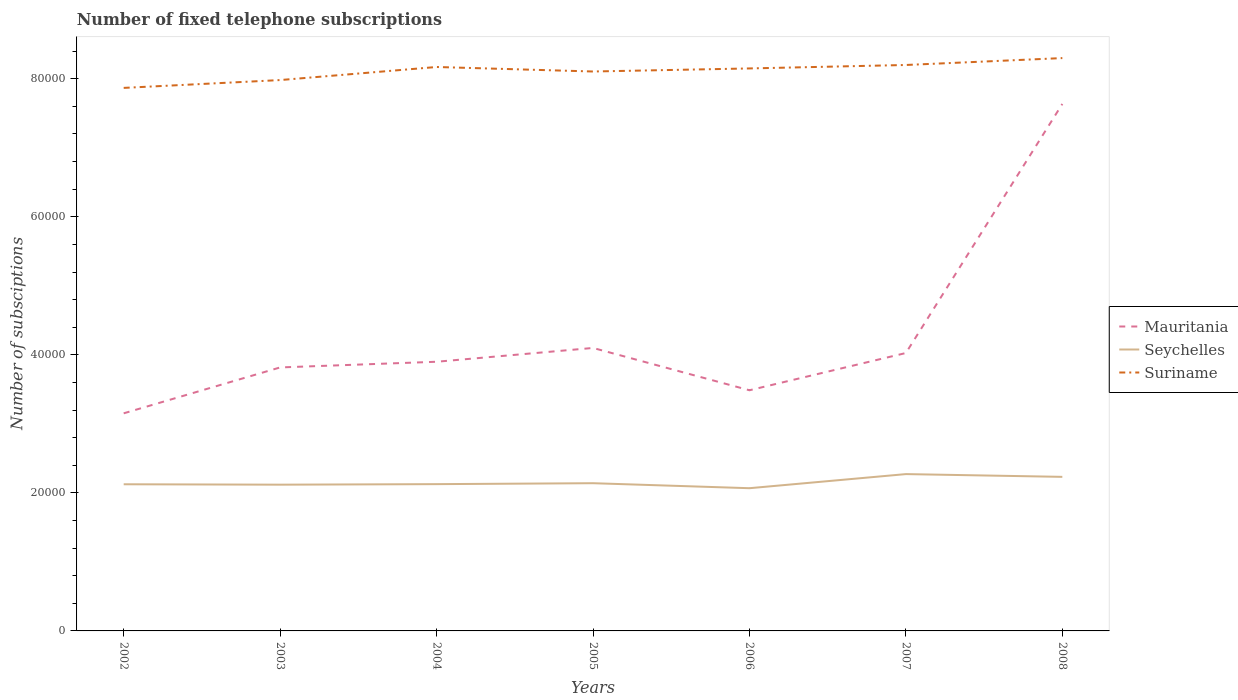Does the line corresponding to Seychelles intersect with the line corresponding to Suriname?
Offer a terse response. No. Is the number of lines equal to the number of legend labels?
Give a very brief answer. Yes. Across all years, what is the maximum number of fixed telephone subscriptions in Suriname?
Ensure brevity in your answer.  7.87e+04. What is the total number of fixed telephone subscriptions in Seychelles in the graph?
Give a very brief answer. -136. What is the difference between the highest and the second highest number of fixed telephone subscriptions in Seychelles?
Offer a terse response. 2043. How many lines are there?
Provide a short and direct response. 3. Does the graph contain any zero values?
Your response must be concise. No. What is the title of the graph?
Your answer should be very brief. Number of fixed telephone subscriptions. What is the label or title of the X-axis?
Provide a succinct answer. Years. What is the label or title of the Y-axis?
Provide a short and direct response. Number of subsciptions. What is the Number of subsciptions in Mauritania in 2002?
Keep it short and to the point. 3.15e+04. What is the Number of subsciptions in Seychelles in 2002?
Keep it short and to the point. 2.12e+04. What is the Number of subsciptions of Suriname in 2002?
Provide a succinct answer. 7.87e+04. What is the Number of subsciptions of Mauritania in 2003?
Ensure brevity in your answer.  3.82e+04. What is the Number of subsciptions of Seychelles in 2003?
Your answer should be compact. 2.12e+04. What is the Number of subsciptions in Suriname in 2003?
Offer a very short reply. 7.98e+04. What is the Number of subsciptions of Mauritania in 2004?
Your answer should be very brief. 3.90e+04. What is the Number of subsciptions in Seychelles in 2004?
Make the answer very short. 2.13e+04. What is the Number of subsciptions in Suriname in 2004?
Your response must be concise. 8.17e+04. What is the Number of subsciptions in Mauritania in 2005?
Give a very brief answer. 4.10e+04. What is the Number of subsciptions of Seychelles in 2005?
Your answer should be compact. 2.14e+04. What is the Number of subsciptions of Suriname in 2005?
Make the answer very short. 8.11e+04. What is the Number of subsciptions in Mauritania in 2006?
Give a very brief answer. 3.49e+04. What is the Number of subsciptions of Seychelles in 2006?
Keep it short and to the point. 2.07e+04. What is the Number of subsciptions of Suriname in 2006?
Give a very brief answer. 8.15e+04. What is the Number of subsciptions of Mauritania in 2007?
Your answer should be compact. 4.03e+04. What is the Number of subsciptions of Seychelles in 2007?
Offer a terse response. 2.27e+04. What is the Number of subsciptions of Suriname in 2007?
Ensure brevity in your answer.  8.20e+04. What is the Number of subsciptions in Mauritania in 2008?
Your answer should be compact. 7.64e+04. What is the Number of subsciptions in Seychelles in 2008?
Your answer should be compact. 2.23e+04. What is the Number of subsciptions of Suriname in 2008?
Ensure brevity in your answer.  8.30e+04. Across all years, what is the maximum Number of subsciptions in Mauritania?
Ensure brevity in your answer.  7.64e+04. Across all years, what is the maximum Number of subsciptions in Seychelles?
Your response must be concise. 2.27e+04. Across all years, what is the maximum Number of subsciptions of Suriname?
Your response must be concise. 8.30e+04. Across all years, what is the minimum Number of subsciptions in Mauritania?
Your answer should be compact. 3.15e+04. Across all years, what is the minimum Number of subsciptions of Seychelles?
Your response must be concise. 2.07e+04. Across all years, what is the minimum Number of subsciptions in Suriname?
Provide a short and direct response. 7.87e+04. What is the total Number of subsciptions of Mauritania in the graph?
Your answer should be compact. 3.01e+05. What is the total Number of subsciptions in Seychelles in the graph?
Offer a terse response. 1.51e+05. What is the total Number of subsciptions in Suriname in the graph?
Your response must be concise. 5.68e+05. What is the difference between the Number of subsciptions of Mauritania in 2002 and that in 2003?
Your answer should be compact. -6649. What is the difference between the Number of subsciptions of Suriname in 2002 and that in 2003?
Provide a short and direct response. -1135. What is the difference between the Number of subsciptions of Mauritania in 2002 and that in 2004?
Your answer should be compact. -7471. What is the difference between the Number of subsciptions in Suriname in 2002 and that in 2004?
Provide a succinct answer. -3029. What is the difference between the Number of subsciptions of Mauritania in 2002 and that in 2005?
Your answer should be very brief. -9471. What is the difference between the Number of subsciptions in Seychelles in 2002 and that in 2005?
Your answer should be compact. -155. What is the difference between the Number of subsciptions in Suriname in 2002 and that in 2005?
Your answer should be very brief. -2376. What is the difference between the Number of subsciptions of Mauritania in 2002 and that in 2006?
Make the answer very short. -3341. What is the difference between the Number of subsciptions of Seychelles in 2002 and that in 2006?
Offer a terse response. 570. What is the difference between the Number of subsciptions in Suriname in 2002 and that in 2006?
Provide a short and direct response. -2820. What is the difference between the Number of subsciptions of Mauritania in 2002 and that in 2007?
Provide a short and direct response. -8738. What is the difference between the Number of subsciptions of Seychelles in 2002 and that in 2007?
Keep it short and to the point. -1473. What is the difference between the Number of subsciptions in Suriname in 2002 and that in 2007?
Offer a very short reply. -3320. What is the difference between the Number of subsciptions in Mauritania in 2002 and that in 2008?
Your answer should be very brief. -4.48e+04. What is the difference between the Number of subsciptions of Seychelles in 2002 and that in 2008?
Provide a succinct answer. -1073. What is the difference between the Number of subsciptions in Suriname in 2002 and that in 2008?
Offer a terse response. -4320. What is the difference between the Number of subsciptions of Mauritania in 2003 and that in 2004?
Your answer should be very brief. -822. What is the difference between the Number of subsciptions of Seychelles in 2003 and that in 2004?
Provide a short and direct response. -77. What is the difference between the Number of subsciptions in Suriname in 2003 and that in 2004?
Keep it short and to the point. -1894. What is the difference between the Number of subsciptions of Mauritania in 2003 and that in 2005?
Your answer should be compact. -2822. What is the difference between the Number of subsciptions of Seychelles in 2003 and that in 2005?
Ensure brevity in your answer.  -213. What is the difference between the Number of subsciptions in Suriname in 2003 and that in 2005?
Provide a succinct answer. -1241. What is the difference between the Number of subsciptions of Mauritania in 2003 and that in 2006?
Your answer should be very brief. 3308. What is the difference between the Number of subsciptions in Seychelles in 2003 and that in 2006?
Provide a short and direct response. 512. What is the difference between the Number of subsciptions in Suriname in 2003 and that in 2006?
Provide a succinct answer. -1685. What is the difference between the Number of subsciptions in Mauritania in 2003 and that in 2007?
Give a very brief answer. -2089. What is the difference between the Number of subsciptions of Seychelles in 2003 and that in 2007?
Ensure brevity in your answer.  -1531. What is the difference between the Number of subsciptions of Suriname in 2003 and that in 2007?
Offer a terse response. -2185. What is the difference between the Number of subsciptions in Mauritania in 2003 and that in 2008?
Your answer should be compact. -3.82e+04. What is the difference between the Number of subsciptions in Seychelles in 2003 and that in 2008?
Your answer should be compact. -1131. What is the difference between the Number of subsciptions of Suriname in 2003 and that in 2008?
Make the answer very short. -3185. What is the difference between the Number of subsciptions in Mauritania in 2004 and that in 2005?
Provide a short and direct response. -2000. What is the difference between the Number of subsciptions of Seychelles in 2004 and that in 2005?
Your response must be concise. -136. What is the difference between the Number of subsciptions in Suriname in 2004 and that in 2005?
Your response must be concise. 653. What is the difference between the Number of subsciptions of Mauritania in 2004 and that in 2006?
Your response must be concise. 4130. What is the difference between the Number of subsciptions in Seychelles in 2004 and that in 2006?
Keep it short and to the point. 589. What is the difference between the Number of subsciptions in Suriname in 2004 and that in 2006?
Offer a terse response. 209. What is the difference between the Number of subsciptions of Mauritania in 2004 and that in 2007?
Provide a succinct answer. -1267. What is the difference between the Number of subsciptions in Seychelles in 2004 and that in 2007?
Offer a terse response. -1454. What is the difference between the Number of subsciptions in Suriname in 2004 and that in 2007?
Your answer should be compact. -291. What is the difference between the Number of subsciptions of Mauritania in 2004 and that in 2008?
Keep it short and to the point. -3.74e+04. What is the difference between the Number of subsciptions in Seychelles in 2004 and that in 2008?
Provide a succinct answer. -1054. What is the difference between the Number of subsciptions of Suriname in 2004 and that in 2008?
Ensure brevity in your answer.  -1291. What is the difference between the Number of subsciptions in Mauritania in 2005 and that in 2006?
Give a very brief answer. 6130. What is the difference between the Number of subsciptions of Seychelles in 2005 and that in 2006?
Your answer should be compact. 725. What is the difference between the Number of subsciptions in Suriname in 2005 and that in 2006?
Your answer should be very brief. -444. What is the difference between the Number of subsciptions of Mauritania in 2005 and that in 2007?
Keep it short and to the point. 733. What is the difference between the Number of subsciptions in Seychelles in 2005 and that in 2007?
Your answer should be very brief. -1318. What is the difference between the Number of subsciptions of Suriname in 2005 and that in 2007?
Your response must be concise. -944. What is the difference between the Number of subsciptions in Mauritania in 2005 and that in 2008?
Keep it short and to the point. -3.54e+04. What is the difference between the Number of subsciptions of Seychelles in 2005 and that in 2008?
Ensure brevity in your answer.  -918. What is the difference between the Number of subsciptions of Suriname in 2005 and that in 2008?
Give a very brief answer. -1944. What is the difference between the Number of subsciptions of Mauritania in 2006 and that in 2007?
Your answer should be very brief. -5397. What is the difference between the Number of subsciptions of Seychelles in 2006 and that in 2007?
Ensure brevity in your answer.  -2043. What is the difference between the Number of subsciptions in Suriname in 2006 and that in 2007?
Offer a terse response. -500. What is the difference between the Number of subsciptions in Mauritania in 2006 and that in 2008?
Your answer should be very brief. -4.15e+04. What is the difference between the Number of subsciptions in Seychelles in 2006 and that in 2008?
Your answer should be compact. -1643. What is the difference between the Number of subsciptions of Suriname in 2006 and that in 2008?
Offer a terse response. -1500. What is the difference between the Number of subsciptions of Mauritania in 2007 and that in 2008?
Your answer should be compact. -3.61e+04. What is the difference between the Number of subsciptions in Suriname in 2007 and that in 2008?
Your answer should be compact. -1000. What is the difference between the Number of subsciptions in Mauritania in 2002 and the Number of subsciptions in Seychelles in 2003?
Offer a terse response. 1.03e+04. What is the difference between the Number of subsciptions in Mauritania in 2002 and the Number of subsciptions in Suriname in 2003?
Your answer should be very brief. -4.83e+04. What is the difference between the Number of subsciptions in Seychelles in 2002 and the Number of subsciptions in Suriname in 2003?
Offer a terse response. -5.86e+04. What is the difference between the Number of subsciptions in Mauritania in 2002 and the Number of subsciptions in Seychelles in 2004?
Provide a succinct answer. 1.03e+04. What is the difference between the Number of subsciptions of Mauritania in 2002 and the Number of subsciptions of Suriname in 2004?
Your answer should be very brief. -5.02e+04. What is the difference between the Number of subsciptions in Seychelles in 2002 and the Number of subsciptions in Suriname in 2004?
Keep it short and to the point. -6.05e+04. What is the difference between the Number of subsciptions in Mauritania in 2002 and the Number of subsciptions in Seychelles in 2005?
Offer a terse response. 1.01e+04. What is the difference between the Number of subsciptions in Mauritania in 2002 and the Number of subsciptions in Suriname in 2005?
Ensure brevity in your answer.  -4.95e+04. What is the difference between the Number of subsciptions of Seychelles in 2002 and the Number of subsciptions of Suriname in 2005?
Provide a short and direct response. -5.98e+04. What is the difference between the Number of subsciptions of Mauritania in 2002 and the Number of subsciptions of Seychelles in 2006?
Your response must be concise. 1.08e+04. What is the difference between the Number of subsciptions of Mauritania in 2002 and the Number of subsciptions of Suriname in 2006?
Your answer should be compact. -5.00e+04. What is the difference between the Number of subsciptions of Seychelles in 2002 and the Number of subsciptions of Suriname in 2006?
Offer a very short reply. -6.03e+04. What is the difference between the Number of subsciptions of Mauritania in 2002 and the Number of subsciptions of Seychelles in 2007?
Make the answer very short. 8807. What is the difference between the Number of subsciptions in Mauritania in 2002 and the Number of subsciptions in Suriname in 2007?
Make the answer very short. -5.05e+04. What is the difference between the Number of subsciptions in Seychelles in 2002 and the Number of subsciptions in Suriname in 2007?
Your answer should be very brief. -6.08e+04. What is the difference between the Number of subsciptions in Mauritania in 2002 and the Number of subsciptions in Seychelles in 2008?
Keep it short and to the point. 9207. What is the difference between the Number of subsciptions in Mauritania in 2002 and the Number of subsciptions in Suriname in 2008?
Provide a succinct answer. -5.15e+04. What is the difference between the Number of subsciptions of Seychelles in 2002 and the Number of subsciptions of Suriname in 2008?
Offer a terse response. -6.18e+04. What is the difference between the Number of subsciptions in Mauritania in 2003 and the Number of subsciptions in Seychelles in 2004?
Your answer should be very brief. 1.69e+04. What is the difference between the Number of subsciptions in Mauritania in 2003 and the Number of subsciptions in Suriname in 2004?
Your response must be concise. -4.35e+04. What is the difference between the Number of subsciptions of Seychelles in 2003 and the Number of subsciptions of Suriname in 2004?
Ensure brevity in your answer.  -6.05e+04. What is the difference between the Number of subsciptions of Mauritania in 2003 and the Number of subsciptions of Seychelles in 2005?
Keep it short and to the point. 1.68e+04. What is the difference between the Number of subsciptions of Mauritania in 2003 and the Number of subsciptions of Suriname in 2005?
Your response must be concise. -4.29e+04. What is the difference between the Number of subsciptions in Seychelles in 2003 and the Number of subsciptions in Suriname in 2005?
Keep it short and to the point. -5.99e+04. What is the difference between the Number of subsciptions in Mauritania in 2003 and the Number of subsciptions in Seychelles in 2006?
Your response must be concise. 1.75e+04. What is the difference between the Number of subsciptions of Mauritania in 2003 and the Number of subsciptions of Suriname in 2006?
Offer a terse response. -4.33e+04. What is the difference between the Number of subsciptions in Seychelles in 2003 and the Number of subsciptions in Suriname in 2006?
Keep it short and to the point. -6.03e+04. What is the difference between the Number of subsciptions in Mauritania in 2003 and the Number of subsciptions in Seychelles in 2007?
Your response must be concise. 1.55e+04. What is the difference between the Number of subsciptions in Mauritania in 2003 and the Number of subsciptions in Suriname in 2007?
Give a very brief answer. -4.38e+04. What is the difference between the Number of subsciptions in Seychelles in 2003 and the Number of subsciptions in Suriname in 2007?
Your response must be concise. -6.08e+04. What is the difference between the Number of subsciptions in Mauritania in 2003 and the Number of subsciptions in Seychelles in 2008?
Make the answer very short. 1.59e+04. What is the difference between the Number of subsciptions in Mauritania in 2003 and the Number of subsciptions in Suriname in 2008?
Offer a terse response. -4.48e+04. What is the difference between the Number of subsciptions of Seychelles in 2003 and the Number of subsciptions of Suriname in 2008?
Provide a succinct answer. -6.18e+04. What is the difference between the Number of subsciptions in Mauritania in 2004 and the Number of subsciptions in Seychelles in 2005?
Keep it short and to the point. 1.76e+04. What is the difference between the Number of subsciptions in Mauritania in 2004 and the Number of subsciptions in Suriname in 2005?
Your answer should be very brief. -4.21e+04. What is the difference between the Number of subsciptions of Seychelles in 2004 and the Number of subsciptions of Suriname in 2005?
Provide a short and direct response. -5.98e+04. What is the difference between the Number of subsciptions of Mauritania in 2004 and the Number of subsciptions of Seychelles in 2006?
Give a very brief answer. 1.83e+04. What is the difference between the Number of subsciptions in Mauritania in 2004 and the Number of subsciptions in Suriname in 2006?
Provide a succinct answer. -4.25e+04. What is the difference between the Number of subsciptions of Seychelles in 2004 and the Number of subsciptions of Suriname in 2006?
Provide a succinct answer. -6.02e+04. What is the difference between the Number of subsciptions of Mauritania in 2004 and the Number of subsciptions of Seychelles in 2007?
Make the answer very short. 1.63e+04. What is the difference between the Number of subsciptions in Mauritania in 2004 and the Number of subsciptions in Suriname in 2007?
Offer a terse response. -4.30e+04. What is the difference between the Number of subsciptions of Seychelles in 2004 and the Number of subsciptions of Suriname in 2007?
Keep it short and to the point. -6.07e+04. What is the difference between the Number of subsciptions in Mauritania in 2004 and the Number of subsciptions in Seychelles in 2008?
Your response must be concise. 1.67e+04. What is the difference between the Number of subsciptions in Mauritania in 2004 and the Number of subsciptions in Suriname in 2008?
Your answer should be very brief. -4.40e+04. What is the difference between the Number of subsciptions of Seychelles in 2004 and the Number of subsciptions of Suriname in 2008?
Your answer should be compact. -6.17e+04. What is the difference between the Number of subsciptions of Mauritania in 2005 and the Number of subsciptions of Seychelles in 2006?
Provide a short and direct response. 2.03e+04. What is the difference between the Number of subsciptions of Mauritania in 2005 and the Number of subsciptions of Suriname in 2006?
Make the answer very short. -4.05e+04. What is the difference between the Number of subsciptions in Seychelles in 2005 and the Number of subsciptions in Suriname in 2006?
Offer a terse response. -6.01e+04. What is the difference between the Number of subsciptions of Mauritania in 2005 and the Number of subsciptions of Seychelles in 2007?
Keep it short and to the point. 1.83e+04. What is the difference between the Number of subsciptions of Mauritania in 2005 and the Number of subsciptions of Suriname in 2007?
Give a very brief answer. -4.10e+04. What is the difference between the Number of subsciptions in Seychelles in 2005 and the Number of subsciptions in Suriname in 2007?
Provide a short and direct response. -6.06e+04. What is the difference between the Number of subsciptions of Mauritania in 2005 and the Number of subsciptions of Seychelles in 2008?
Provide a succinct answer. 1.87e+04. What is the difference between the Number of subsciptions of Mauritania in 2005 and the Number of subsciptions of Suriname in 2008?
Your answer should be compact. -4.20e+04. What is the difference between the Number of subsciptions in Seychelles in 2005 and the Number of subsciptions in Suriname in 2008?
Provide a succinct answer. -6.16e+04. What is the difference between the Number of subsciptions of Mauritania in 2006 and the Number of subsciptions of Seychelles in 2007?
Give a very brief answer. 1.21e+04. What is the difference between the Number of subsciptions of Mauritania in 2006 and the Number of subsciptions of Suriname in 2007?
Ensure brevity in your answer.  -4.71e+04. What is the difference between the Number of subsciptions of Seychelles in 2006 and the Number of subsciptions of Suriname in 2007?
Your answer should be very brief. -6.13e+04. What is the difference between the Number of subsciptions of Mauritania in 2006 and the Number of subsciptions of Seychelles in 2008?
Make the answer very short. 1.25e+04. What is the difference between the Number of subsciptions in Mauritania in 2006 and the Number of subsciptions in Suriname in 2008?
Your answer should be compact. -4.81e+04. What is the difference between the Number of subsciptions of Seychelles in 2006 and the Number of subsciptions of Suriname in 2008?
Your response must be concise. -6.23e+04. What is the difference between the Number of subsciptions in Mauritania in 2007 and the Number of subsciptions in Seychelles in 2008?
Keep it short and to the point. 1.79e+04. What is the difference between the Number of subsciptions in Mauritania in 2007 and the Number of subsciptions in Suriname in 2008?
Make the answer very short. -4.27e+04. What is the difference between the Number of subsciptions in Seychelles in 2007 and the Number of subsciptions in Suriname in 2008?
Give a very brief answer. -6.03e+04. What is the average Number of subsciptions in Mauritania per year?
Keep it short and to the point. 4.30e+04. What is the average Number of subsciptions in Seychelles per year?
Your answer should be compact. 2.15e+04. What is the average Number of subsciptions in Suriname per year?
Provide a succinct answer. 8.11e+04. In the year 2002, what is the difference between the Number of subsciptions in Mauritania and Number of subsciptions in Seychelles?
Provide a succinct answer. 1.03e+04. In the year 2002, what is the difference between the Number of subsciptions of Mauritania and Number of subsciptions of Suriname?
Keep it short and to the point. -4.72e+04. In the year 2002, what is the difference between the Number of subsciptions in Seychelles and Number of subsciptions in Suriname?
Your answer should be very brief. -5.74e+04. In the year 2003, what is the difference between the Number of subsciptions of Mauritania and Number of subsciptions of Seychelles?
Make the answer very short. 1.70e+04. In the year 2003, what is the difference between the Number of subsciptions in Mauritania and Number of subsciptions in Suriname?
Your response must be concise. -4.16e+04. In the year 2003, what is the difference between the Number of subsciptions of Seychelles and Number of subsciptions of Suriname?
Provide a succinct answer. -5.86e+04. In the year 2004, what is the difference between the Number of subsciptions of Mauritania and Number of subsciptions of Seychelles?
Your answer should be compact. 1.77e+04. In the year 2004, what is the difference between the Number of subsciptions of Mauritania and Number of subsciptions of Suriname?
Make the answer very short. -4.27e+04. In the year 2004, what is the difference between the Number of subsciptions in Seychelles and Number of subsciptions in Suriname?
Make the answer very short. -6.04e+04. In the year 2005, what is the difference between the Number of subsciptions of Mauritania and Number of subsciptions of Seychelles?
Your response must be concise. 1.96e+04. In the year 2005, what is the difference between the Number of subsciptions in Mauritania and Number of subsciptions in Suriname?
Your answer should be very brief. -4.01e+04. In the year 2005, what is the difference between the Number of subsciptions of Seychelles and Number of subsciptions of Suriname?
Your response must be concise. -5.97e+04. In the year 2006, what is the difference between the Number of subsciptions of Mauritania and Number of subsciptions of Seychelles?
Your response must be concise. 1.42e+04. In the year 2006, what is the difference between the Number of subsciptions in Mauritania and Number of subsciptions in Suriname?
Your answer should be very brief. -4.66e+04. In the year 2006, what is the difference between the Number of subsciptions of Seychelles and Number of subsciptions of Suriname?
Keep it short and to the point. -6.08e+04. In the year 2007, what is the difference between the Number of subsciptions in Mauritania and Number of subsciptions in Seychelles?
Provide a short and direct response. 1.75e+04. In the year 2007, what is the difference between the Number of subsciptions of Mauritania and Number of subsciptions of Suriname?
Your response must be concise. -4.17e+04. In the year 2007, what is the difference between the Number of subsciptions of Seychelles and Number of subsciptions of Suriname?
Offer a terse response. -5.93e+04. In the year 2008, what is the difference between the Number of subsciptions in Mauritania and Number of subsciptions in Seychelles?
Your answer should be compact. 5.40e+04. In the year 2008, what is the difference between the Number of subsciptions in Mauritania and Number of subsciptions in Suriname?
Give a very brief answer. -6646. In the year 2008, what is the difference between the Number of subsciptions of Seychelles and Number of subsciptions of Suriname?
Make the answer very short. -6.07e+04. What is the ratio of the Number of subsciptions of Mauritania in 2002 to that in 2003?
Provide a succinct answer. 0.83. What is the ratio of the Number of subsciptions in Seychelles in 2002 to that in 2003?
Ensure brevity in your answer.  1. What is the ratio of the Number of subsciptions of Suriname in 2002 to that in 2003?
Ensure brevity in your answer.  0.99. What is the ratio of the Number of subsciptions in Mauritania in 2002 to that in 2004?
Your response must be concise. 0.81. What is the ratio of the Number of subsciptions of Suriname in 2002 to that in 2004?
Provide a short and direct response. 0.96. What is the ratio of the Number of subsciptions of Mauritania in 2002 to that in 2005?
Your response must be concise. 0.77. What is the ratio of the Number of subsciptions of Seychelles in 2002 to that in 2005?
Give a very brief answer. 0.99. What is the ratio of the Number of subsciptions of Suriname in 2002 to that in 2005?
Offer a very short reply. 0.97. What is the ratio of the Number of subsciptions of Mauritania in 2002 to that in 2006?
Provide a short and direct response. 0.9. What is the ratio of the Number of subsciptions in Seychelles in 2002 to that in 2006?
Keep it short and to the point. 1.03. What is the ratio of the Number of subsciptions in Suriname in 2002 to that in 2006?
Make the answer very short. 0.97. What is the ratio of the Number of subsciptions in Mauritania in 2002 to that in 2007?
Offer a terse response. 0.78. What is the ratio of the Number of subsciptions in Seychelles in 2002 to that in 2007?
Provide a short and direct response. 0.94. What is the ratio of the Number of subsciptions of Suriname in 2002 to that in 2007?
Offer a very short reply. 0.96. What is the ratio of the Number of subsciptions in Mauritania in 2002 to that in 2008?
Provide a succinct answer. 0.41. What is the ratio of the Number of subsciptions of Seychelles in 2002 to that in 2008?
Ensure brevity in your answer.  0.95. What is the ratio of the Number of subsciptions of Suriname in 2002 to that in 2008?
Give a very brief answer. 0.95. What is the ratio of the Number of subsciptions in Mauritania in 2003 to that in 2004?
Make the answer very short. 0.98. What is the ratio of the Number of subsciptions of Seychelles in 2003 to that in 2004?
Make the answer very short. 1. What is the ratio of the Number of subsciptions of Suriname in 2003 to that in 2004?
Keep it short and to the point. 0.98. What is the ratio of the Number of subsciptions in Mauritania in 2003 to that in 2005?
Provide a succinct answer. 0.93. What is the ratio of the Number of subsciptions in Seychelles in 2003 to that in 2005?
Your response must be concise. 0.99. What is the ratio of the Number of subsciptions in Suriname in 2003 to that in 2005?
Keep it short and to the point. 0.98. What is the ratio of the Number of subsciptions of Mauritania in 2003 to that in 2006?
Provide a succinct answer. 1.09. What is the ratio of the Number of subsciptions of Seychelles in 2003 to that in 2006?
Offer a terse response. 1.02. What is the ratio of the Number of subsciptions in Suriname in 2003 to that in 2006?
Your answer should be compact. 0.98. What is the ratio of the Number of subsciptions in Mauritania in 2003 to that in 2007?
Your answer should be compact. 0.95. What is the ratio of the Number of subsciptions of Seychelles in 2003 to that in 2007?
Your answer should be very brief. 0.93. What is the ratio of the Number of subsciptions in Suriname in 2003 to that in 2007?
Provide a succinct answer. 0.97. What is the ratio of the Number of subsciptions of Mauritania in 2003 to that in 2008?
Keep it short and to the point. 0.5. What is the ratio of the Number of subsciptions in Seychelles in 2003 to that in 2008?
Your answer should be compact. 0.95. What is the ratio of the Number of subsciptions in Suriname in 2003 to that in 2008?
Ensure brevity in your answer.  0.96. What is the ratio of the Number of subsciptions in Mauritania in 2004 to that in 2005?
Your answer should be very brief. 0.95. What is the ratio of the Number of subsciptions in Seychelles in 2004 to that in 2005?
Ensure brevity in your answer.  0.99. What is the ratio of the Number of subsciptions in Mauritania in 2004 to that in 2006?
Your answer should be very brief. 1.12. What is the ratio of the Number of subsciptions in Seychelles in 2004 to that in 2006?
Make the answer very short. 1.03. What is the ratio of the Number of subsciptions in Mauritania in 2004 to that in 2007?
Keep it short and to the point. 0.97. What is the ratio of the Number of subsciptions in Seychelles in 2004 to that in 2007?
Ensure brevity in your answer.  0.94. What is the ratio of the Number of subsciptions of Mauritania in 2004 to that in 2008?
Make the answer very short. 0.51. What is the ratio of the Number of subsciptions in Seychelles in 2004 to that in 2008?
Give a very brief answer. 0.95. What is the ratio of the Number of subsciptions of Suriname in 2004 to that in 2008?
Ensure brevity in your answer.  0.98. What is the ratio of the Number of subsciptions in Mauritania in 2005 to that in 2006?
Give a very brief answer. 1.18. What is the ratio of the Number of subsciptions in Seychelles in 2005 to that in 2006?
Your answer should be very brief. 1.04. What is the ratio of the Number of subsciptions of Suriname in 2005 to that in 2006?
Keep it short and to the point. 0.99. What is the ratio of the Number of subsciptions in Mauritania in 2005 to that in 2007?
Ensure brevity in your answer.  1.02. What is the ratio of the Number of subsciptions of Seychelles in 2005 to that in 2007?
Keep it short and to the point. 0.94. What is the ratio of the Number of subsciptions of Suriname in 2005 to that in 2007?
Provide a short and direct response. 0.99. What is the ratio of the Number of subsciptions of Mauritania in 2005 to that in 2008?
Make the answer very short. 0.54. What is the ratio of the Number of subsciptions of Seychelles in 2005 to that in 2008?
Make the answer very short. 0.96. What is the ratio of the Number of subsciptions of Suriname in 2005 to that in 2008?
Provide a succinct answer. 0.98. What is the ratio of the Number of subsciptions of Mauritania in 2006 to that in 2007?
Your answer should be very brief. 0.87. What is the ratio of the Number of subsciptions of Seychelles in 2006 to that in 2007?
Your answer should be very brief. 0.91. What is the ratio of the Number of subsciptions in Suriname in 2006 to that in 2007?
Provide a short and direct response. 0.99. What is the ratio of the Number of subsciptions of Mauritania in 2006 to that in 2008?
Provide a succinct answer. 0.46. What is the ratio of the Number of subsciptions in Seychelles in 2006 to that in 2008?
Offer a terse response. 0.93. What is the ratio of the Number of subsciptions of Suriname in 2006 to that in 2008?
Provide a succinct answer. 0.98. What is the ratio of the Number of subsciptions in Mauritania in 2007 to that in 2008?
Give a very brief answer. 0.53. What is the ratio of the Number of subsciptions in Seychelles in 2007 to that in 2008?
Your answer should be compact. 1.02. What is the ratio of the Number of subsciptions of Suriname in 2007 to that in 2008?
Offer a terse response. 0.99. What is the difference between the highest and the second highest Number of subsciptions of Mauritania?
Provide a short and direct response. 3.54e+04. What is the difference between the highest and the second highest Number of subsciptions in Seychelles?
Make the answer very short. 400. What is the difference between the highest and the lowest Number of subsciptions of Mauritania?
Offer a terse response. 4.48e+04. What is the difference between the highest and the lowest Number of subsciptions in Seychelles?
Your answer should be compact. 2043. What is the difference between the highest and the lowest Number of subsciptions in Suriname?
Provide a short and direct response. 4320. 